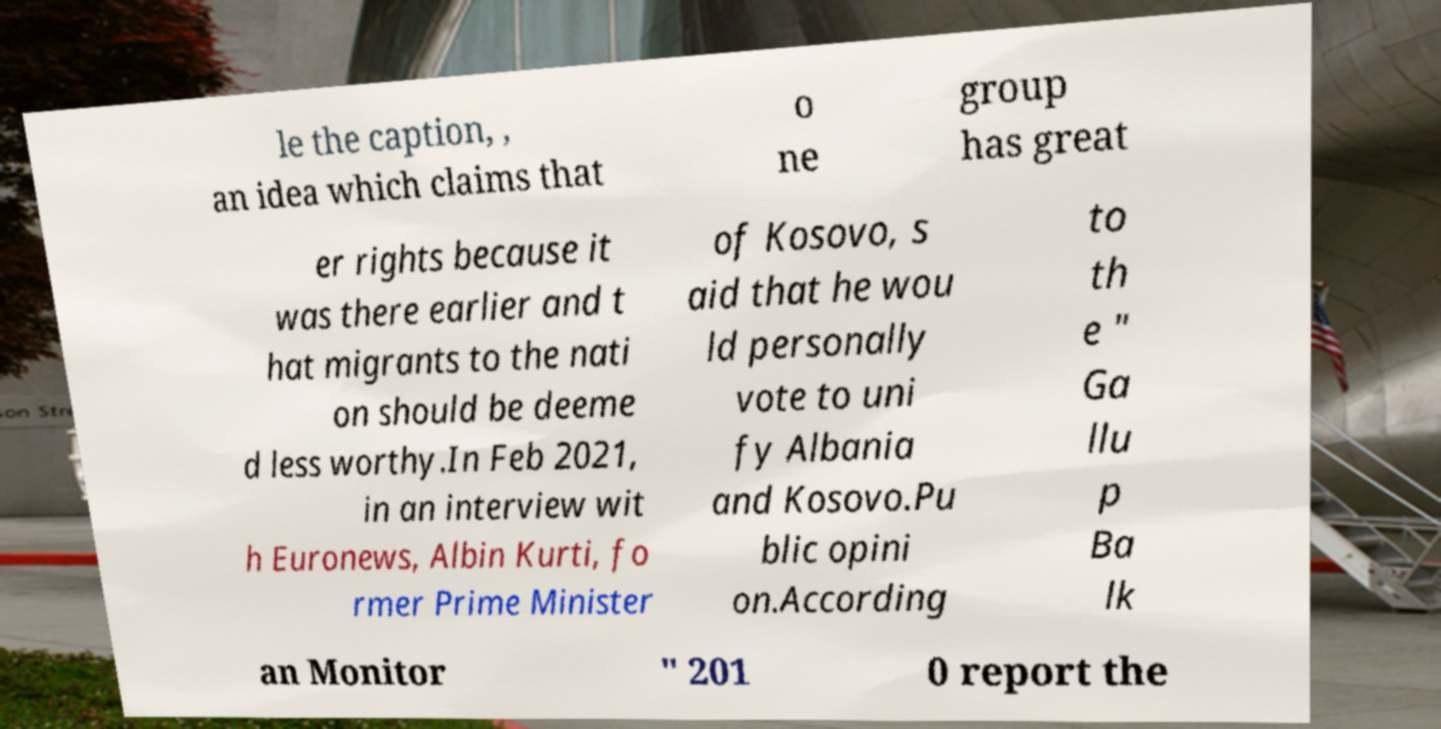Could you assist in decoding the text presented in this image and type it out clearly? le the caption, , an idea which claims that o ne group has great er rights because it was there earlier and t hat migrants to the nati on should be deeme d less worthy.In Feb 2021, in an interview wit h Euronews, Albin Kurti, fo rmer Prime Minister of Kosovo, s aid that he wou ld personally vote to uni fy Albania and Kosovo.Pu blic opini on.According to th e " Ga llu p Ba lk an Monitor " 201 0 report the 